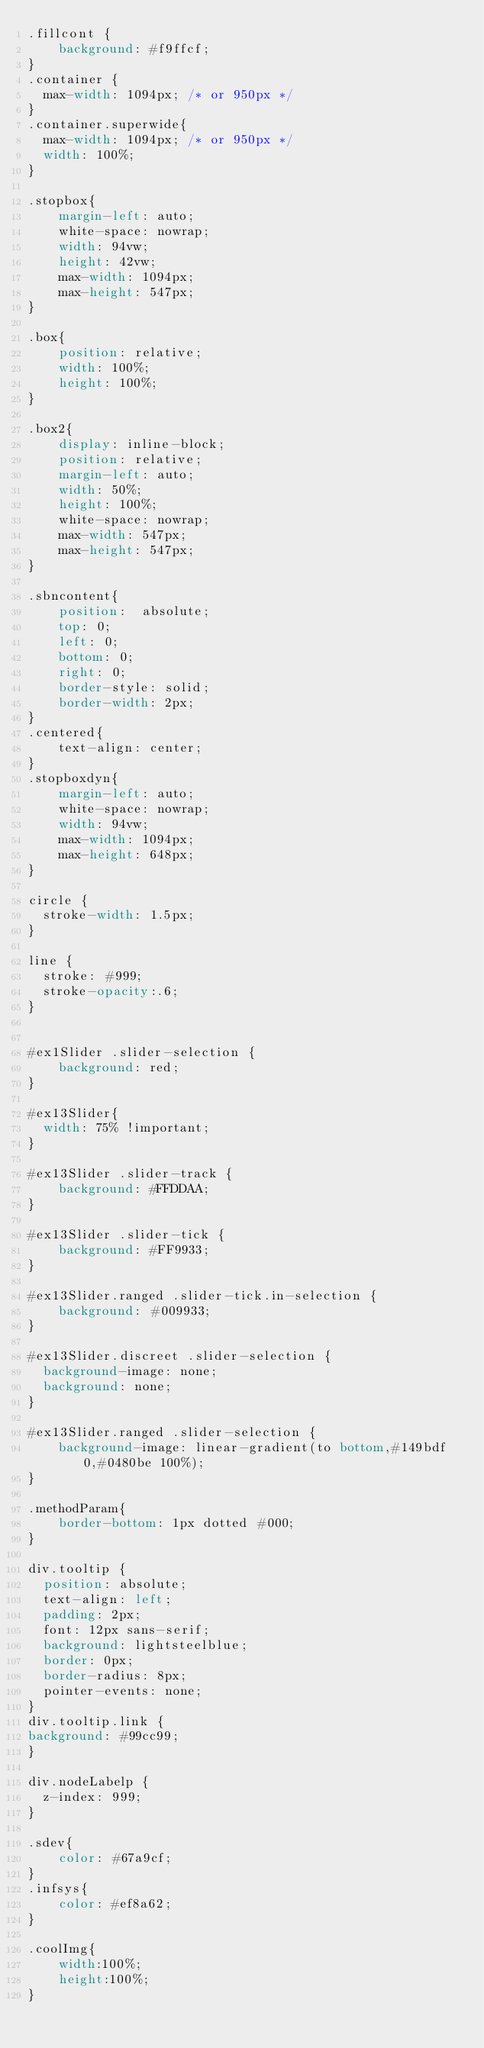Convert code to text. <code><loc_0><loc_0><loc_500><loc_500><_CSS_>.fillcont { 
    background: #f9ffcf;
}
.container {
  max-width: 1094px; /* or 950px */
}
.container.superwide{
  max-width: 1094px; /* or 950px */
  width: 100%;
}

.stopbox{
	margin-left: auto;
	white-space: nowrap;
	width: 94vw;
	height: 42vw;
	max-width: 1094px;
	max-height: 547px;
}

.box{
	position: relative;
	width: 100%;
	height: 100%;
}

.box2{
	display: inline-block;
	position: relative;
	margin-left: auto;
	width: 50%;
	height: 100%;
	white-space: nowrap;
	max-width: 547px;
	max-height: 547px;
}

.sbncontent{
	position:  absolute;
	top: 0;
	left: 0;
	bottom: 0;
	right: 0;
	border-style: solid;
	border-width: 2px;
}
.centered{
	text-align: center;
}
.stopboxdyn{
	margin-left: auto;
	white-space: nowrap;
	width: 94vw;
	max-width: 1094px;
	max-height: 648px;
}

circle {
  stroke-width: 1.5px;
}

line {
  stroke: #999;
  stroke-opacity:.6;
}


#ex1Slider .slider-selection {
	background: red;
}

#ex13Slider{
  width: 75% !important;
}

#ex13Slider .slider-track {
	background: #FFDDAA;
}

#ex13Slider .slider-tick {
	background: #FF9933;
}

#ex13Slider.ranged .slider-tick.in-selection {
	background: #009933;
}

#ex13Slider.discreet .slider-selection {
  background-image: none;
  background: none;
}

#ex13Slider.ranged .slider-selection {
	background-image: linear-gradient(to bottom,#149bdf 0,#0480be 100%);
}

.methodParam{
	border-bottom: 1px dotted #000;
}

div.tooltip {   
  position: absolute;           
  text-align: left;                           
  padding: 2px;             
  font: 12px sans-serif;        
  background: lightsteelblue;   
  border: 0px;      
  border-radius: 8px;           
  pointer-events: none;         
}
div.tooltip.link {   
background: #99cc99;  
}

div.nodeLabelp {   
  z-index: 999;        
}

.sdev{
	color: #67a9cf;
}
.infsys{
	color: #ef8a62;
}

.coolImg{
	width:100%;
	height:100%;
}</code> 